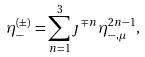<formula> <loc_0><loc_0><loc_500><loc_500>\eta _ { - } ^ { ( \pm ) } = \sum _ { n = 1 } ^ { 3 } \jmath ^ { \mp n } \eta ^ { 2 n - 1 } _ { - , \mu } ,</formula> 